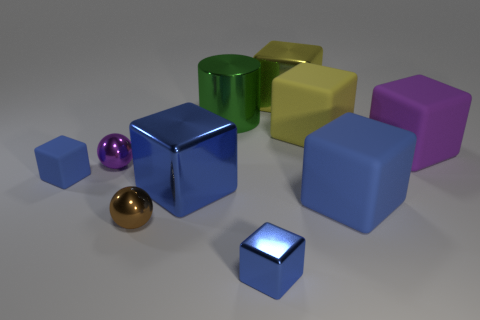Subtract all blue cubes. How many were subtracted if there are1blue cubes left? 3 Subtract all yellow matte blocks. How many blocks are left? 6 Subtract all yellow blocks. How many blocks are left? 5 Subtract all blue cylinders. How many yellow blocks are left? 2 Subtract 1 balls. How many balls are left? 1 Subtract all red blocks. Subtract all purple cylinders. How many blocks are left? 7 Subtract all blue metallic cubes. Subtract all purple cubes. How many objects are left? 7 Add 4 big cylinders. How many big cylinders are left? 5 Add 4 big purple things. How many big purple things exist? 5 Subtract 0 green spheres. How many objects are left? 10 